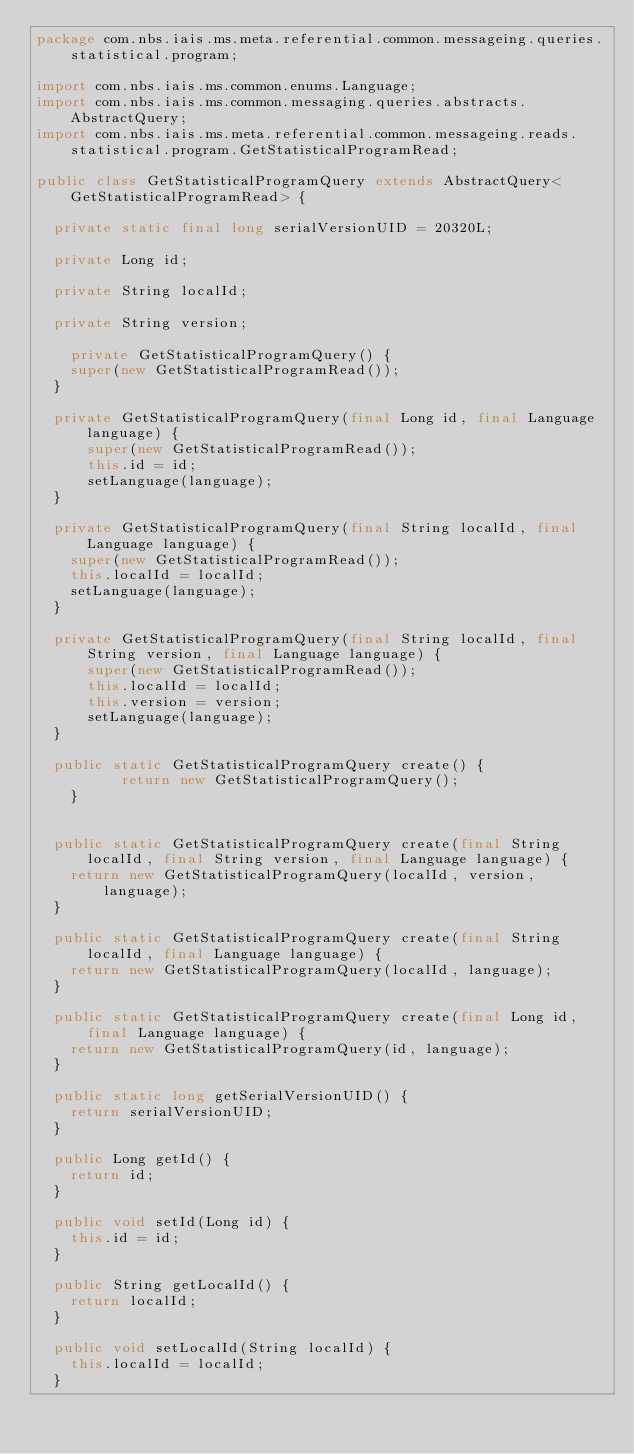Convert code to text. <code><loc_0><loc_0><loc_500><loc_500><_Java_>package com.nbs.iais.ms.meta.referential.common.messageing.queries.statistical.program;

import com.nbs.iais.ms.common.enums.Language;
import com.nbs.iais.ms.common.messaging.queries.abstracts.AbstractQuery;
import com.nbs.iais.ms.meta.referential.common.messageing.reads.statistical.program.GetStatisticalProgramRead;

public class GetStatisticalProgramQuery extends AbstractQuery<GetStatisticalProgramRead> {

	private static final long serialVersionUID = 20320L;

	private Long id;

	private String localId;

	private String version;
	
    private GetStatisticalProgramQuery() {
		super(new GetStatisticalProgramRead());
	}

	private GetStatisticalProgramQuery(final Long id, final Language language) {
    	super(new GetStatisticalProgramRead());
    	this.id = id;
    	setLanguage(language);
	}

	private GetStatisticalProgramQuery(final String localId, final Language language) {
		super(new GetStatisticalProgramRead());
		this.localId = localId;
		setLanguage(language);
	}

	private GetStatisticalProgramQuery(final String localId, final String version, final Language language) {
    	super(new GetStatisticalProgramRead());
    	this.localId = localId;
    	this.version = version;
    	setLanguage(language);
	}

	public static GetStatisticalProgramQuery create() {
	        return new GetStatisticalProgramQuery();
    }


	public static GetStatisticalProgramQuery create(final String localId, final String version, final Language language) {
		return new GetStatisticalProgramQuery(localId, version, language);
	}

	public static GetStatisticalProgramQuery create(final String localId, final Language language) {
		return new GetStatisticalProgramQuery(localId, language);
	}

	public static GetStatisticalProgramQuery create(final Long id, final Language language) {
		return new GetStatisticalProgramQuery(id, language);
	}

	public static long getSerialVersionUID() {
		return serialVersionUID;
	}

	public Long getId() {
		return id;
	}

	public void setId(Long id) {
		this.id = id;
	}

	public String getLocalId() {
		return localId;
	}

	public void setLocalId(String localId) {
		this.localId = localId;
	}
</code> 